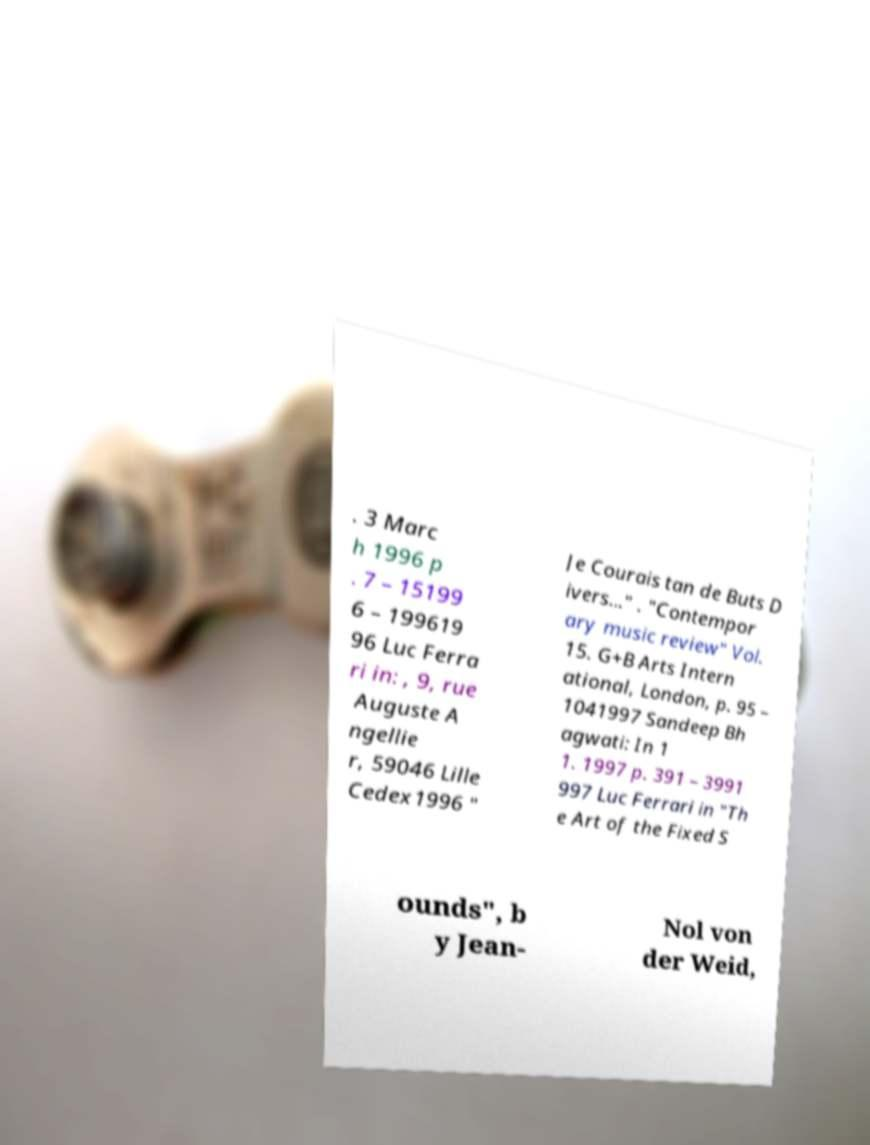I need the written content from this picture converted into text. Can you do that? . 3 Marc h 1996 p . 7 – 15199 6 – 199619 96 Luc Ferra ri in: , 9, rue Auguste A ngellie r, 59046 Lille Cedex1996 " Je Courais tan de Buts D ivers..." . "Contempor ary music review" Vol. 15. G+B Arts Intern ational, London, p. 95 – 1041997 Sandeep Bh agwati: In 1 1. 1997 p. 391 – 3991 997 Luc Ferrari in "Th e Art of the Fixed S ounds", b y Jean- Nol von der Weid, 